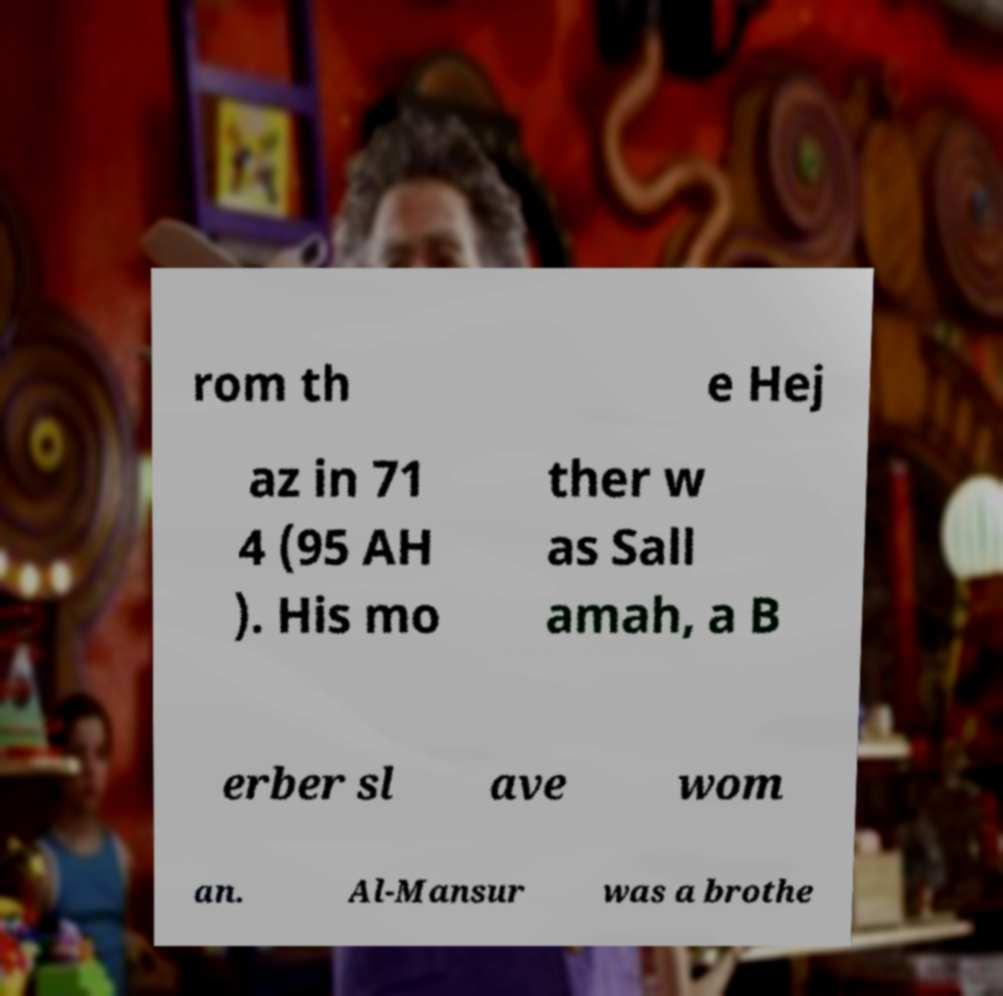Can you read and provide the text displayed in the image?This photo seems to have some interesting text. Can you extract and type it out for me? rom th e Hej az in 71 4 (95 AH ). His mo ther w as Sall amah, a B erber sl ave wom an. Al-Mansur was a brothe 